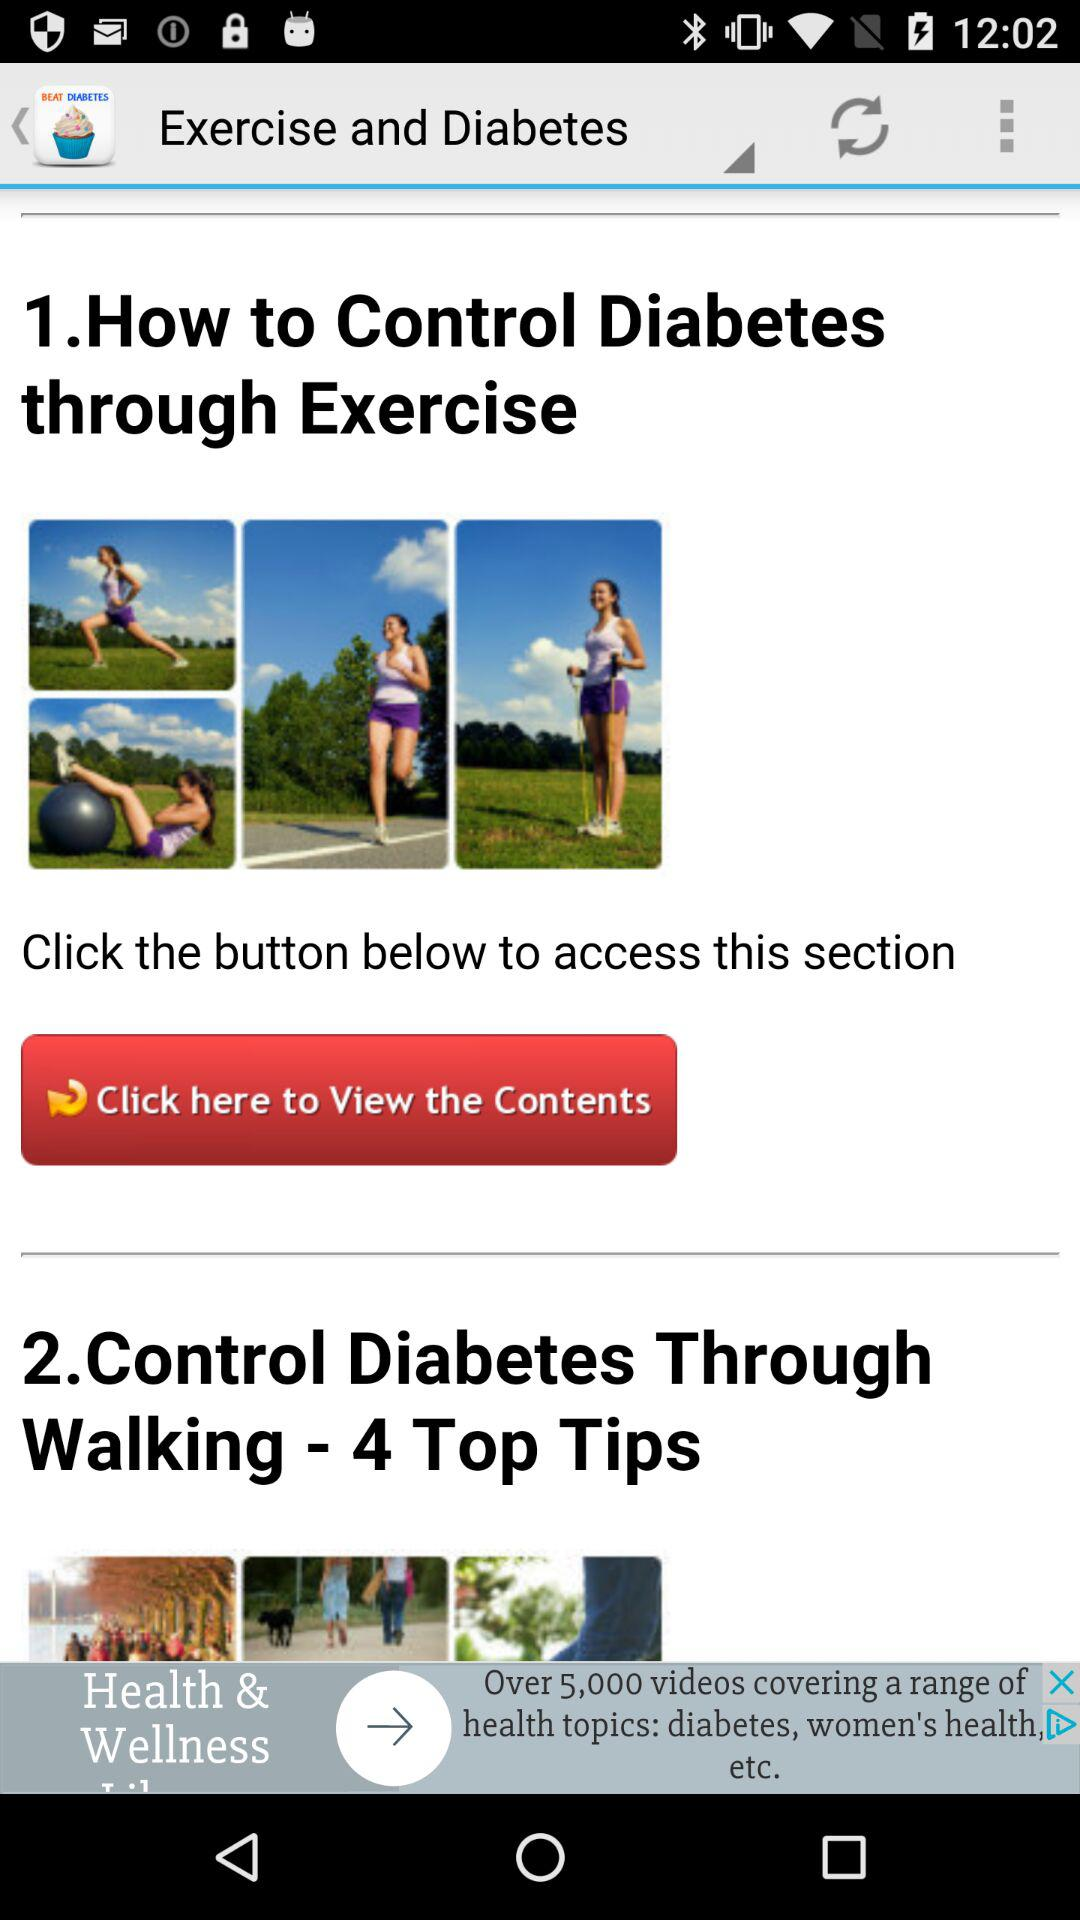How many top tips are there for controlling diabetes through walking? There are 4 top tips for controlling diabetes through walking. 